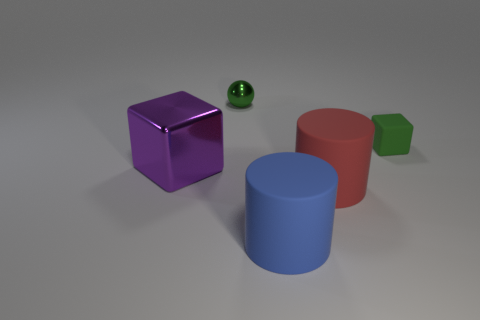What could be the possible sizes of these objects in a real-world setting? It's challenging to ascertain the exact sizes without a reference object. However, judging by the context they are normally presented in, the cylinders could be similar to the size of large drinking cups or small stools, while the blocks could be compared to small boxes or dice. 